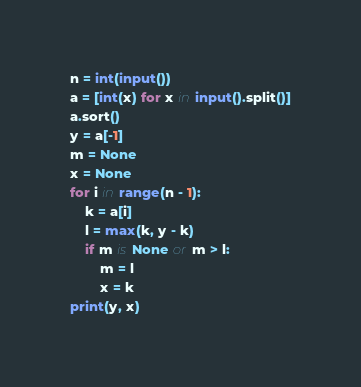<code> <loc_0><loc_0><loc_500><loc_500><_Python_>n = int(input())
a = [int(x) for x in input().split()]
a.sort()
y = a[-1]
m = None
x = None
for i in range(n - 1):
    k = a[i]
    l = max(k, y - k)
    if m is None or m > l:
        m = l
        x = k
print(y, x)
</code> 